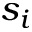Convert formula to latex. <formula><loc_0><loc_0><loc_500><loc_500>s _ { i }</formula> 